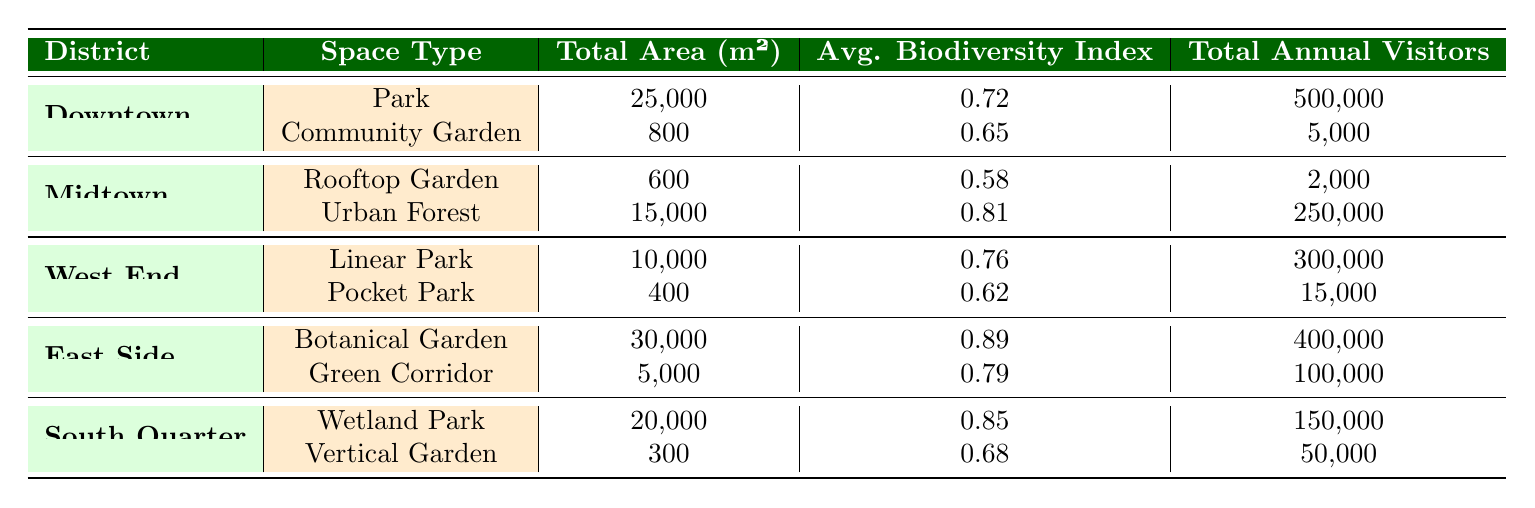What district has the highest annual visitors? By evaluating the "Total Annual Visitors" column for each district, we can see that "Downtown" has 500,000 visitors from its park and "East Side" has 400,000 from its botanical garden and green corridor. "Downtown" has the highest count.
Answer: Downtown What is the total area of green spaces in the West End? The total area is calculated by adding the area of the "Linear Park" (10,000 m²) and the "Pocket Park" (400 m²), which gives us 10,000 + 400 = 10,400 m².
Answer: 10,400 m² Is the biodiversity index of the Botanical Garden higher than that of the Urban Forest? The biodiversity index of the "Botanical Garden" (0.89) is greater than that of the "Urban Forest" (0.81), making this statement true.
Answer: Yes What is the average biodiversity index for green spaces in the South Quarter? The biodiversity index for the "Wetland Park" is 0.85 and for the "Vertical Garden" is 0.68. The average is calculated as (0.85 + 0.68) / 2 = 0.765.
Answer: 0.765 Which district has the least number of tree species? By inspecting the "tree species" column, "Vertical Garden" in the "South Quarter" possesses only 1 tree species, which is the lowest in the table.
Answer: South Quarter How many total annual visitors do green spaces in Midtown receive? Adding the visitors from "Skyline Oasis" (2,000) and "Maple Grove" (250,000) amounts to 2,000 + 250,000 = 252,000 annual visitors.
Answer: 252,000 Which space type in the East Side has the highest biodiversity index? In "East Side," the "Botanical Garden" has the highest index of 0.89 compared to the "Green Corridor" with 0.79.
Answer: Botanical Garden What is the difference in area between the largest and smallest green spaces across all districts? The largest space is the "Botanical Garden" (30,000 m²) and the smallest is the "Vertical Garden" (300 m²). The difference is 30,000 - 300 = 29,700 m².
Answer: 29,700 m² 